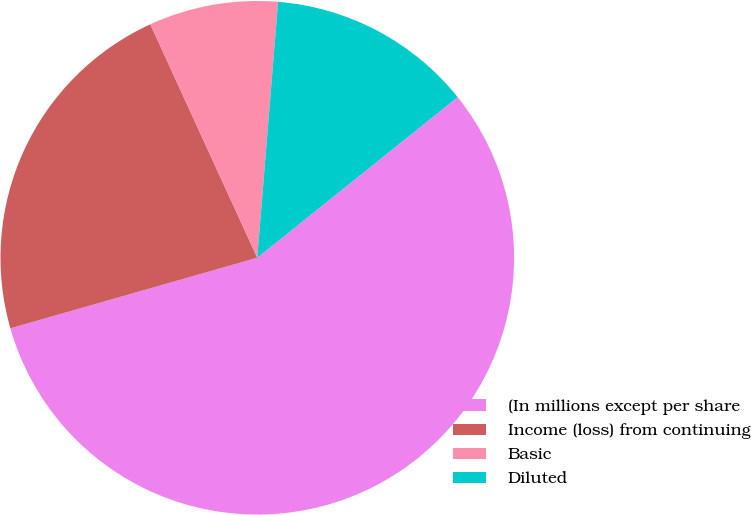Convert chart to OTSL. <chart><loc_0><loc_0><loc_500><loc_500><pie_chart><fcel>(In millions except per share<fcel>Income (loss) from continuing<fcel>Basic<fcel>Diluted<nl><fcel>56.32%<fcel>22.59%<fcel>8.13%<fcel>12.95%<nl></chart> 